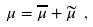<formula> <loc_0><loc_0><loc_500><loc_500>\mu = \overline { \mu } + \widetilde { \mu } \ ,</formula> 